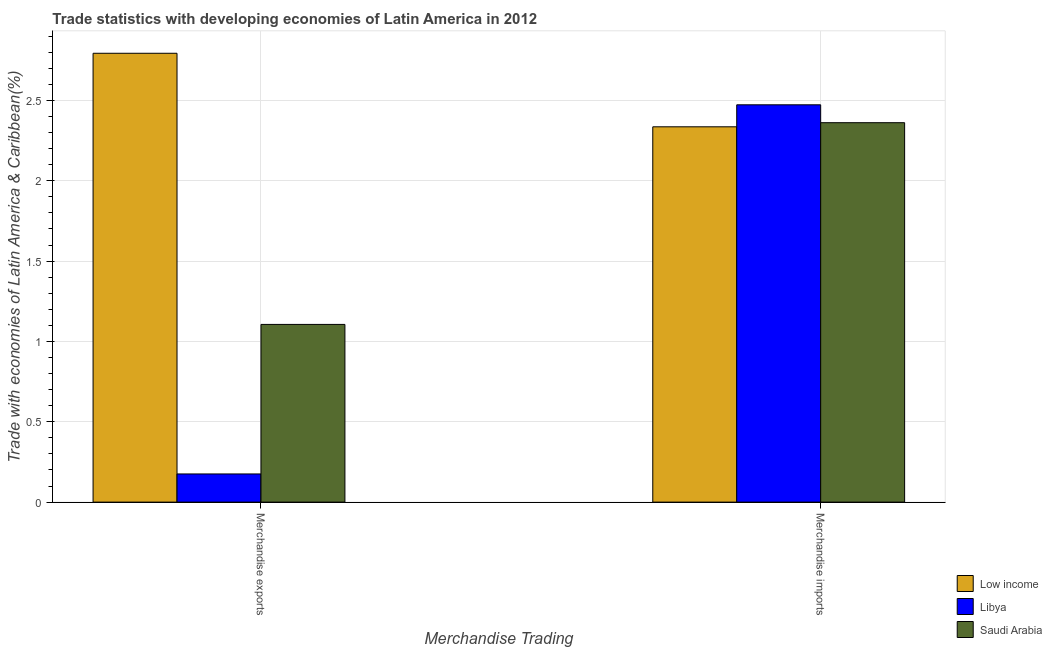How many different coloured bars are there?
Offer a terse response. 3. How many groups of bars are there?
Your response must be concise. 2. How many bars are there on the 2nd tick from the right?
Give a very brief answer. 3. What is the label of the 2nd group of bars from the left?
Offer a very short reply. Merchandise imports. What is the merchandise imports in Libya?
Ensure brevity in your answer.  2.47. Across all countries, what is the maximum merchandise imports?
Ensure brevity in your answer.  2.47. Across all countries, what is the minimum merchandise exports?
Provide a succinct answer. 0.18. In which country was the merchandise imports maximum?
Provide a succinct answer. Libya. In which country was the merchandise imports minimum?
Your answer should be very brief. Low income. What is the total merchandise exports in the graph?
Make the answer very short. 4.08. What is the difference between the merchandise exports in Low income and that in Saudi Arabia?
Offer a terse response. 1.69. What is the difference between the merchandise exports in Saudi Arabia and the merchandise imports in Low income?
Your answer should be very brief. -1.23. What is the average merchandise exports per country?
Keep it short and to the point. 1.36. What is the difference between the merchandise exports and merchandise imports in Low income?
Your response must be concise. 0.46. In how many countries, is the merchandise imports greater than 2.7 %?
Ensure brevity in your answer.  0. What is the ratio of the merchandise imports in Low income to that in Libya?
Give a very brief answer. 0.94. What does the 2nd bar from the left in Merchandise imports represents?
Offer a terse response. Libya. What does the 1st bar from the right in Merchandise imports represents?
Offer a terse response. Saudi Arabia. How many bars are there?
Your answer should be compact. 6. Are all the bars in the graph horizontal?
Make the answer very short. No. Are the values on the major ticks of Y-axis written in scientific E-notation?
Your response must be concise. No. Does the graph contain grids?
Your answer should be very brief. Yes. Where does the legend appear in the graph?
Your answer should be very brief. Bottom right. How many legend labels are there?
Offer a very short reply. 3. How are the legend labels stacked?
Provide a short and direct response. Vertical. What is the title of the graph?
Keep it short and to the point. Trade statistics with developing economies of Latin America in 2012. What is the label or title of the X-axis?
Ensure brevity in your answer.  Merchandise Trading. What is the label or title of the Y-axis?
Provide a succinct answer. Trade with economies of Latin America & Caribbean(%). What is the Trade with economies of Latin America & Caribbean(%) of Low income in Merchandise exports?
Your answer should be very brief. 2.79. What is the Trade with economies of Latin America & Caribbean(%) of Libya in Merchandise exports?
Your response must be concise. 0.18. What is the Trade with economies of Latin America & Caribbean(%) of Saudi Arabia in Merchandise exports?
Your response must be concise. 1.11. What is the Trade with economies of Latin America & Caribbean(%) in Low income in Merchandise imports?
Make the answer very short. 2.34. What is the Trade with economies of Latin America & Caribbean(%) in Libya in Merchandise imports?
Make the answer very short. 2.47. What is the Trade with economies of Latin America & Caribbean(%) in Saudi Arabia in Merchandise imports?
Keep it short and to the point. 2.36. Across all Merchandise Trading, what is the maximum Trade with economies of Latin America & Caribbean(%) in Low income?
Make the answer very short. 2.79. Across all Merchandise Trading, what is the maximum Trade with economies of Latin America & Caribbean(%) in Libya?
Offer a terse response. 2.47. Across all Merchandise Trading, what is the maximum Trade with economies of Latin America & Caribbean(%) in Saudi Arabia?
Offer a very short reply. 2.36. Across all Merchandise Trading, what is the minimum Trade with economies of Latin America & Caribbean(%) in Low income?
Your answer should be compact. 2.34. Across all Merchandise Trading, what is the minimum Trade with economies of Latin America & Caribbean(%) in Libya?
Ensure brevity in your answer.  0.18. Across all Merchandise Trading, what is the minimum Trade with economies of Latin America & Caribbean(%) of Saudi Arabia?
Your answer should be very brief. 1.11. What is the total Trade with economies of Latin America & Caribbean(%) of Low income in the graph?
Provide a short and direct response. 5.13. What is the total Trade with economies of Latin America & Caribbean(%) of Libya in the graph?
Keep it short and to the point. 2.65. What is the total Trade with economies of Latin America & Caribbean(%) of Saudi Arabia in the graph?
Your response must be concise. 3.47. What is the difference between the Trade with economies of Latin America & Caribbean(%) in Low income in Merchandise exports and that in Merchandise imports?
Provide a short and direct response. 0.46. What is the difference between the Trade with economies of Latin America & Caribbean(%) in Libya in Merchandise exports and that in Merchandise imports?
Make the answer very short. -2.3. What is the difference between the Trade with economies of Latin America & Caribbean(%) of Saudi Arabia in Merchandise exports and that in Merchandise imports?
Make the answer very short. -1.26. What is the difference between the Trade with economies of Latin America & Caribbean(%) of Low income in Merchandise exports and the Trade with economies of Latin America & Caribbean(%) of Libya in Merchandise imports?
Your response must be concise. 0.32. What is the difference between the Trade with economies of Latin America & Caribbean(%) of Low income in Merchandise exports and the Trade with economies of Latin America & Caribbean(%) of Saudi Arabia in Merchandise imports?
Your response must be concise. 0.43. What is the difference between the Trade with economies of Latin America & Caribbean(%) of Libya in Merchandise exports and the Trade with economies of Latin America & Caribbean(%) of Saudi Arabia in Merchandise imports?
Give a very brief answer. -2.19. What is the average Trade with economies of Latin America & Caribbean(%) of Low income per Merchandise Trading?
Offer a very short reply. 2.56. What is the average Trade with economies of Latin America & Caribbean(%) in Libya per Merchandise Trading?
Offer a very short reply. 1.32. What is the average Trade with economies of Latin America & Caribbean(%) of Saudi Arabia per Merchandise Trading?
Offer a very short reply. 1.73. What is the difference between the Trade with economies of Latin America & Caribbean(%) of Low income and Trade with economies of Latin America & Caribbean(%) of Libya in Merchandise exports?
Your answer should be compact. 2.62. What is the difference between the Trade with economies of Latin America & Caribbean(%) in Low income and Trade with economies of Latin America & Caribbean(%) in Saudi Arabia in Merchandise exports?
Make the answer very short. 1.69. What is the difference between the Trade with economies of Latin America & Caribbean(%) in Libya and Trade with economies of Latin America & Caribbean(%) in Saudi Arabia in Merchandise exports?
Your answer should be very brief. -0.93. What is the difference between the Trade with economies of Latin America & Caribbean(%) of Low income and Trade with economies of Latin America & Caribbean(%) of Libya in Merchandise imports?
Offer a very short reply. -0.14. What is the difference between the Trade with economies of Latin America & Caribbean(%) of Low income and Trade with economies of Latin America & Caribbean(%) of Saudi Arabia in Merchandise imports?
Ensure brevity in your answer.  -0.03. What is the difference between the Trade with economies of Latin America & Caribbean(%) in Libya and Trade with economies of Latin America & Caribbean(%) in Saudi Arabia in Merchandise imports?
Provide a succinct answer. 0.11. What is the ratio of the Trade with economies of Latin America & Caribbean(%) in Low income in Merchandise exports to that in Merchandise imports?
Your answer should be compact. 1.2. What is the ratio of the Trade with economies of Latin America & Caribbean(%) in Libya in Merchandise exports to that in Merchandise imports?
Make the answer very short. 0.07. What is the ratio of the Trade with economies of Latin America & Caribbean(%) of Saudi Arabia in Merchandise exports to that in Merchandise imports?
Your response must be concise. 0.47. What is the difference between the highest and the second highest Trade with economies of Latin America & Caribbean(%) of Low income?
Ensure brevity in your answer.  0.46. What is the difference between the highest and the second highest Trade with economies of Latin America & Caribbean(%) in Libya?
Provide a succinct answer. 2.3. What is the difference between the highest and the second highest Trade with economies of Latin America & Caribbean(%) of Saudi Arabia?
Ensure brevity in your answer.  1.26. What is the difference between the highest and the lowest Trade with economies of Latin America & Caribbean(%) in Low income?
Offer a very short reply. 0.46. What is the difference between the highest and the lowest Trade with economies of Latin America & Caribbean(%) of Libya?
Provide a succinct answer. 2.3. What is the difference between the highest and the lowest Trade with economies of Latin America & Caribbean(%) of Saudi Arabia?
Make the answer very short. 1.26. 